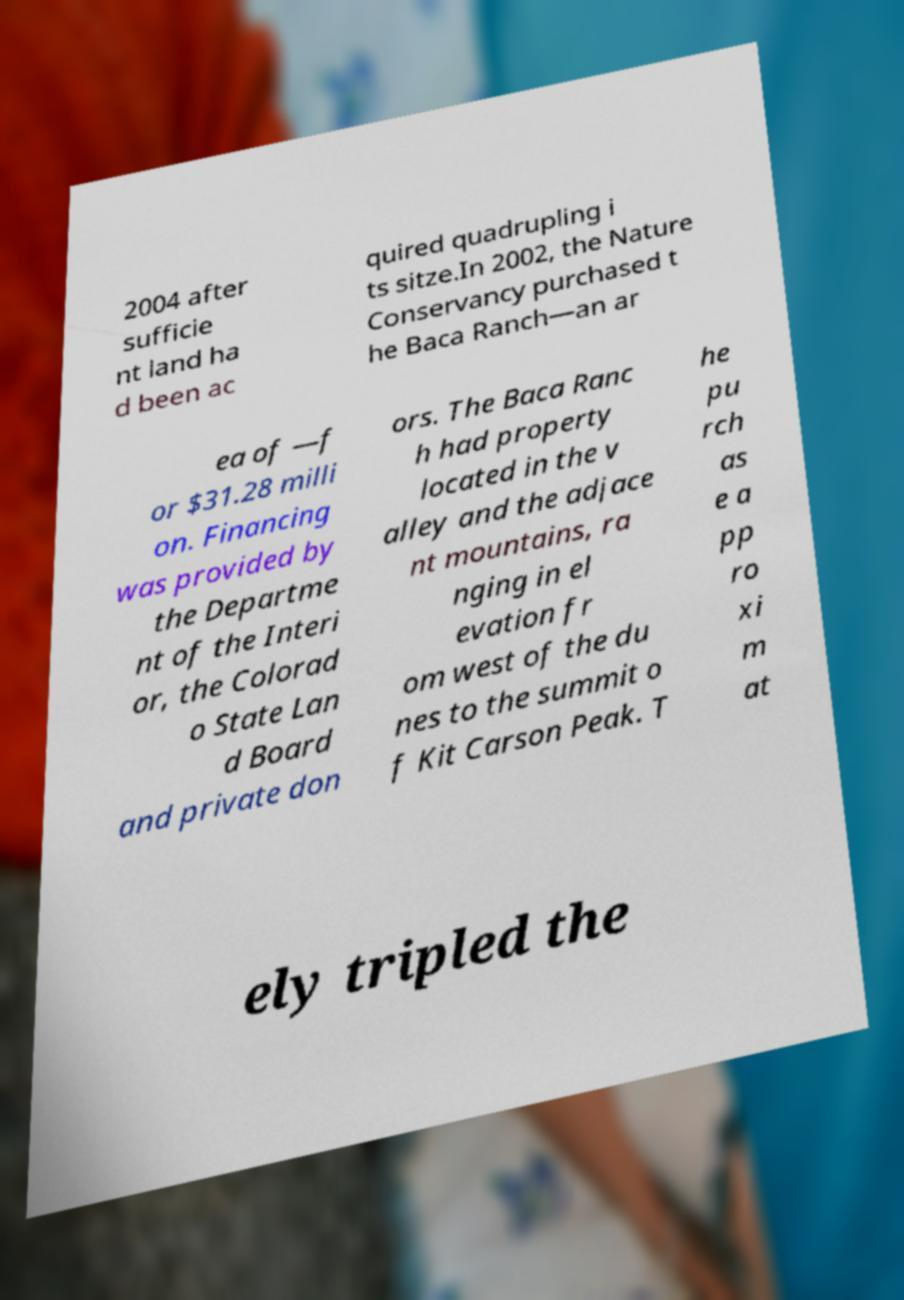Please identify and transcribe the text found in this image. 2004 after sufficie nt land ha d been ac quired quadrupling i ts sitze.In 2002, the Nature Conservancy purchased t he Baca Ranch—an ar ea of —f or $31.28 milli on. Financing was provided by the Departme nt of the Interi or, the Colorad o State Lan d Board and private don ors. The Baca Ranc h had property located in the v alley and the adjace nt mountains, ra nging in el evation fr om west of the du nes to the summit o f Kit Carson Peak. T he pu rch as e a pp ro xi m at ely tripled the 